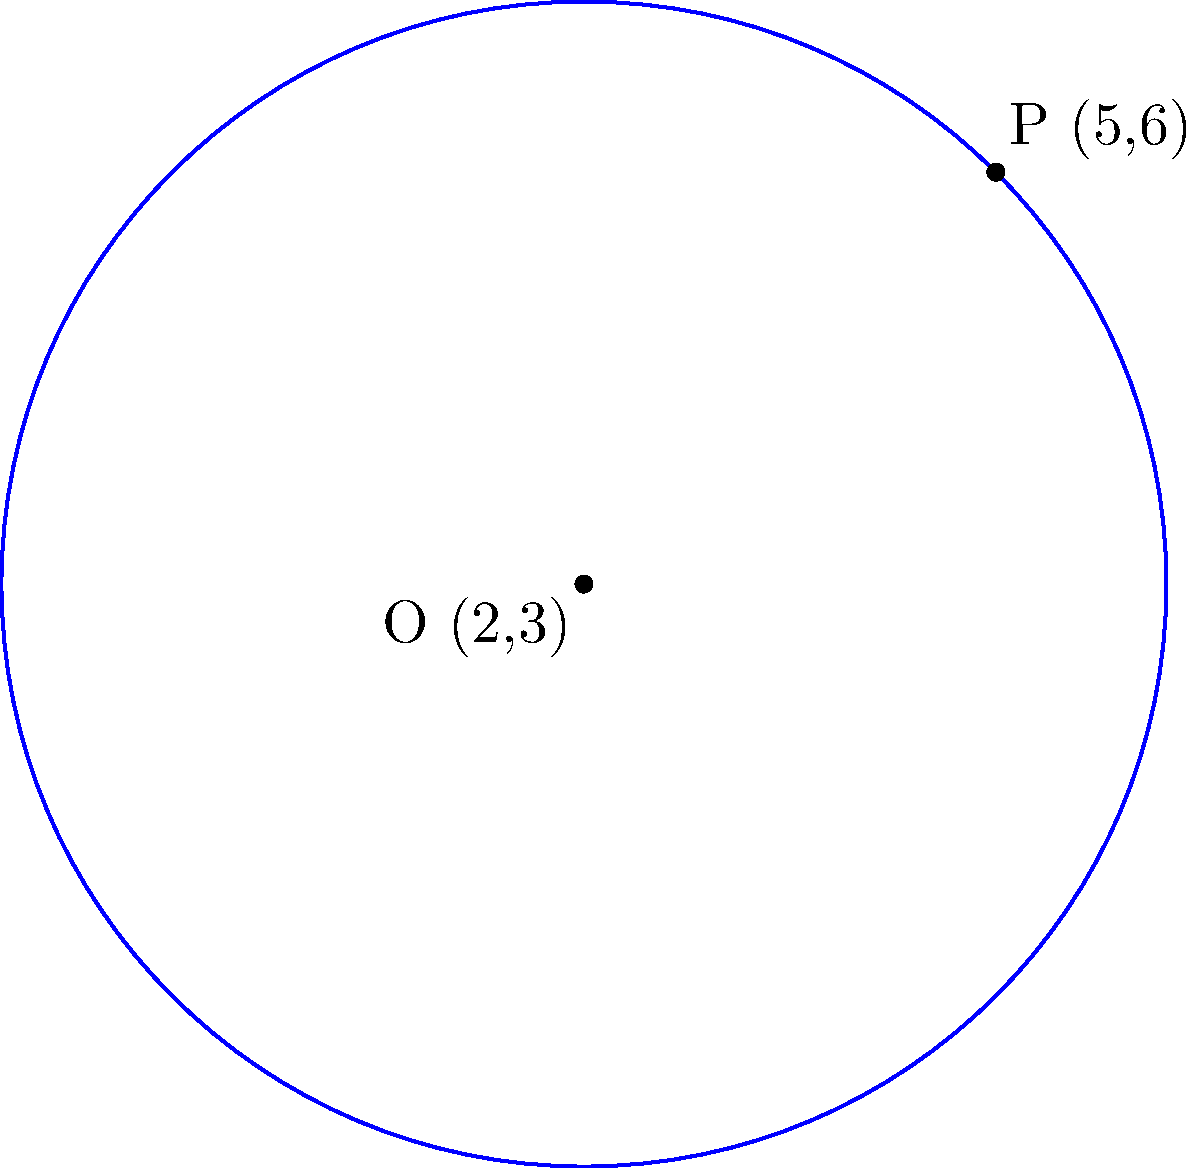Given a circle with center O(2,3) and a point P(5,6) on its circumference, determine the equation of the circle. To find the equation of the circle, we'll use the general form: $$(x-h)^2 + (y-k)^2 = r^2$$
where (h,k) is the center and r is the radius.

Step 1: Identify the center (h,k)
The center O is given as (2,3), so h = 2 and k = 3.

Step 2: Calculate the radius r
We can find the radius by calculating the distance between the center O(2,3) and the point P(5,6) on the circumference:

$$r = \sqrt{(x_P - x_O)^2 + (y_P - y_O)^2}$$
$$r = \sqrt{(5 - 2)^2 + (6 - 3)^2}$$
$$r = \sqrt{3^2 + 3^2} = \sqrt{18} = 3\sqrt{2}$$

Step 3: Substitute the values into the general equation
$$(x-2)^2 + (y-3)^2 = (3\sqrt{2})^2$$

Step 4: Simplify
$$(x-2)^2 + (y-3)^2 = 18$$

This is the equation of the circle.
Answer: $(x-2)^2 + (y-3)^2 = 18$ 